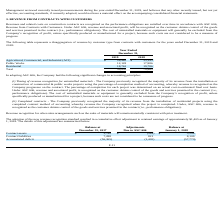According to Sunworks's financial document, How are revenue and associated profit recognised under ASC 606? recognized as the customer obtains control of the goods and services promised in the contract (i.e., performance obligations). The document states: "er ASC 606, revenue and associated profit, will be recognized as the customer obtains control of the goods and services promised in the contract (i.e...." Also, What is the total revenue in 2019? According to the financial document, 59,830. The relevant text states: "Total 59,830 70,965..." Also, What is the revenue from Residential in 2018? According to the financial document, 19,786. The relevant text states: "Residential 18,762 19,786..." Also, can you calculate: What is the percentage change in the revenue from agricultural, commercial and industrial group from 2018 to 2019? To answer this question, I need to perform calculations using the financial data. The calculation is: (28,940-33,193)/33,193, which equals -12.81 (percentage). This is based on the information: "ural, Commercial, and Industrial (ACI) $ 28,940 $ 33,193 Agricultural, Commercial, and Industrial (ACI) $ 28,940 $ 33,193..." The key data points involved are: 28,940, 33,193. Also, can you calculate: What is the percentage change in the revenue from public works from 2018 to 2019? To answer this question, I need to perform calculations using the financial data. The calculation is: (12,128-17,986)/17,986, which equals -32.57 (percentage). This is based on the information: "Public Works 12,128 17,986 Public Works 12,128 17,986..." The key data points involved are: 12,128, 17,986. Also, can you calculate: What is the percent of total revenue from residential in the total revenue for the year ended December 31, 2019? Based on the calculation: 18,762/59,830, the result is 31.36 (percentage). This is based on the information: "Total 59,830 70,965 Residential 18,762 19,786..." The key data points involved are: 18,762, 59,830. Additionally, In which year is the revenue from Agricultural, Commercial, and Industrial (ACI) higher? According to the financial document, 2018. The relevant text states: "2019 2018..." Additionally, In which year is the revenue from Public Works higher? According to the financial document, 2018. The relevant text states: "2019 2018..." 